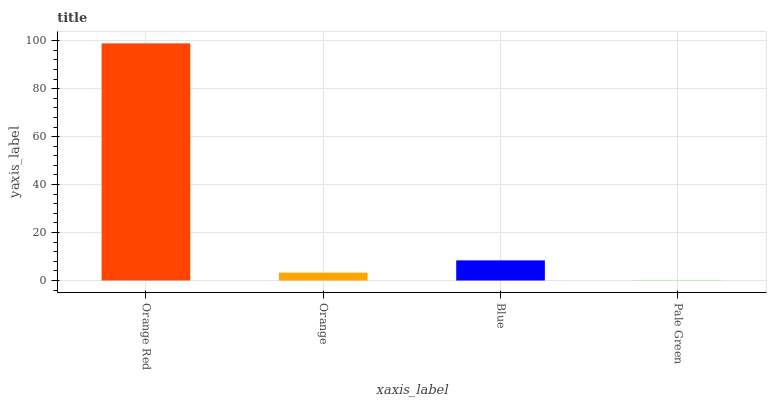Is Pale Green the minimum?
Answer yes or no. Yes. Is Orange Red the maximum?
Answer yes or no. Yes. Is Orange the minimum?
Answer yes or no. No. Is Orange the maximum?
Answer yes or no. No. Is Orange Red greater than Orange?
Answer yes or no. Yes. Is Orange less than Orange Red?
Answer yes or no. Yes. Is Orange greater than Orange Red?
Answer yes or no. No. Is Orange Red less than Orange?
Answer yes or no. No. Is Blue the high median?
Answer yes or no. Yes. Is Orange the low median?
Answer yes or no. Yes. Is Orange Red the high median?
Answer yes or no. No. Is Blue the low median?
Answer yes or no. No. 